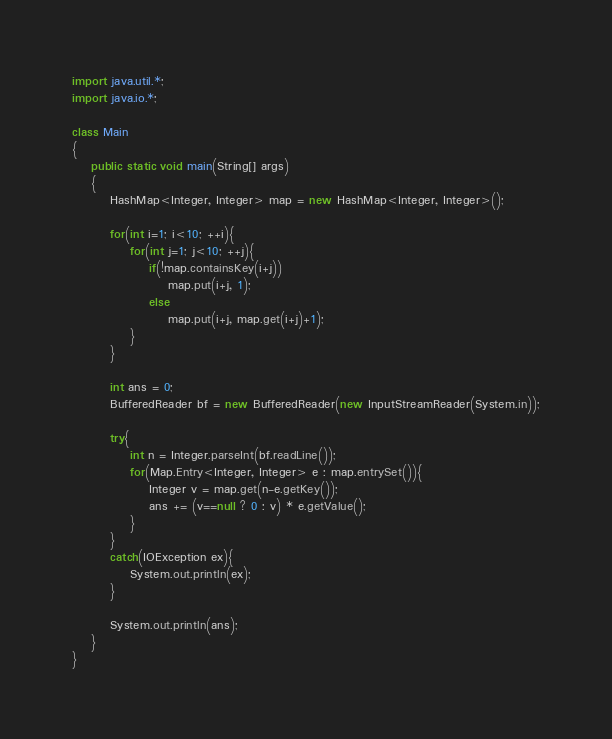Convert code to text. <code><loc_0><loc_0><loc_500><loc_500><_Java_>import java.util.*;
import java.io.*;

class Main
{
	public static void main(String[] args)
	{
		HashMap<Integer, Integer> map = new HashMap<Integer, Integer>();

		for(int i=1; i<10; ++i){
			for(int j=1; j<10; ++j){
				if(!map.containsKey(i+j))
					map.put(i+j, 1);
				else
					map.put(i+j, map.get(i+j)+1);
			}
		}

		int ans = 0;
		BufferedReader bf = new BufferedReader(new InputStreamReader(System.in));

		try{
			int n = Integer.parseInt(bf.readLine());
			for(Map.Entry<Integer, Integer> e : map.entrySet()){
				Integer v = map.get(n-e.getKey());
				ans += (v==null ? 0 : v) * e.getValue();
			}
		}
		catch(IOException ex){
			System.out.println(ex);
		}

		System.out.println(ans);
	}
}</code> 